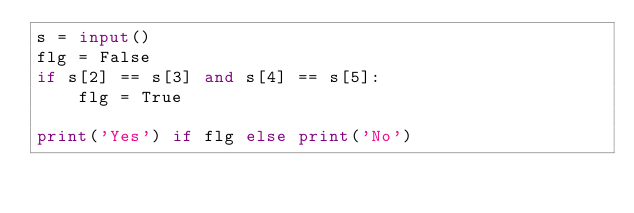<code> <loc_0><loc_0><loc_500><loc_500><_Python_>s = input()
flg = False
if s[2] == s[3] and s[4] == s[5]:
    flg = True

print('Yes') if flg else print('No')</code> 